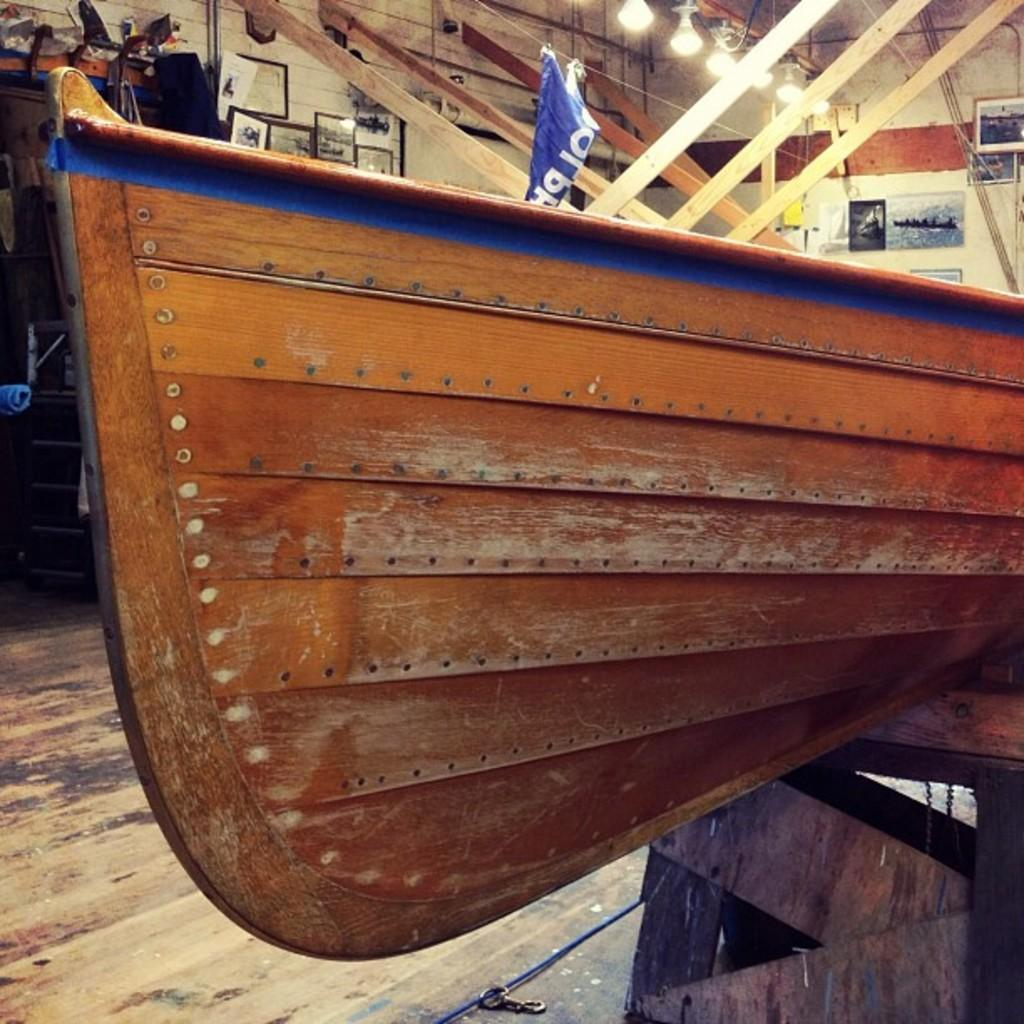What type of object is made of wood in the image? There is a wooden object in the image, but its specific nature is not mentioned. What kind of signage is present in the image? There is a banner in the image. What are the frames used for in the image? The frames in the image are not specified, so their purpose is unclear. What type of illumination is present in the image? There are lights in the image. Can you describe any other objects in the image? There are other unspecified objects in the image, but their nature is not mentioned. What can be seen in the background of the image? There is a wall in the background of the image. How many ducks are jumping on the wooden object in the image? There are no ducks present in the image, and the wooden object is not described in enough detail to determine if it could support jumping. What type of snails can be seen crawling on the banner in the image? There are no snails present in the image, and the banner is not described in enough detail to determine if it could support snails crawling on it. 